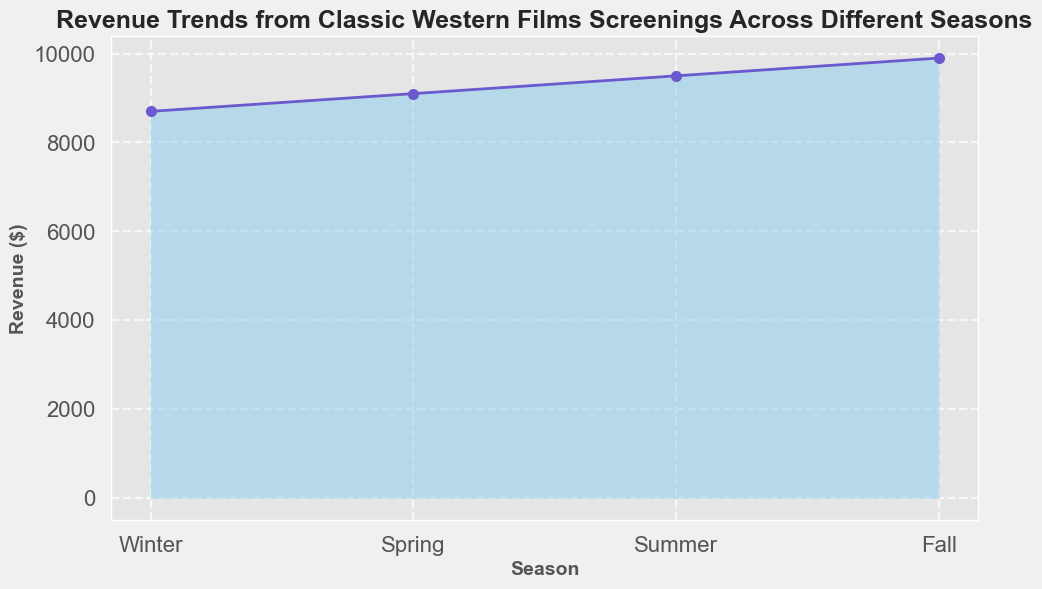What's the revenue in Spring? Looking at the plot, we can see the specific revenue for Spring. The line marking for Spring indicates the revenue in Spring.
Answer: 2600 Which season shows the highest revenue? Observing the plot, the highest point on the filled area indicates the peak revenue across the seasons. From the figure, Summer reaches the highest peak compared to other seasons.
Answer: Summer What is the difference in revenue between Summer and Winter? First, identify the revenue for Summer and Winter from the plot. Summer’s revenue is 3300 and Winter’s is 1800. Calculate the difference: 3300 - 1800 = 1500.
Answer: 1500 What trends can you observe in the revenue across the seasons? By looking at the changes in the revenue marked by the filled area across the seasons, observe that the revenue rises from Winter to Summer and then falls in Fall. This trend repeats consistently.
Answer: Rising in Winter to Summer, falling in Fall During which seasons does the revenue increase the most? From the figure, check the segments where the rise in the graph is steepest. The increase is substantial between Winter and Spring and Summer shows the highest revenue jumps.
Answer: Winter to Summer Is the revenue in Fall consistently higher than in Winter? Observe the plot and compare the line segments for Fall and Winter over the seasons. Fall consistently shows higher revenue compared to Winter.
Answer: Yes How much higher is Spring’s revenue compared to Winter’s? Identify the Spring and Winter revenue figures. Respectively, Spring totals 2600 and Winter totals 1800. Compute the difference: 2600 - 1800 = 800.
Answer: 800 What is the total revenue across all seasons in one full cycle? Extract individual values for each season and sum them up: 1800 (Winter) + 2600 (Spring) + 3300 (Summer) + 2100 (Fall) = 9800.
Answer: 9800 What does the color and fill effect on the graph represent? The sky-blue color fill signifies the area between the x-axis and the revenue line, representing cumulative revenue by season effectively. The visual rising and falling emphasis conveys trends over time.
Answer: Revenue trends visually 